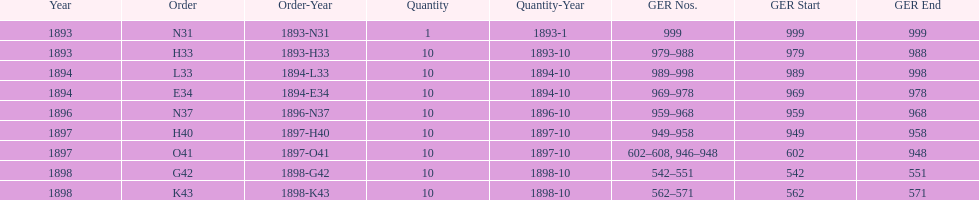How mans years have ger nos below 900? 2. 